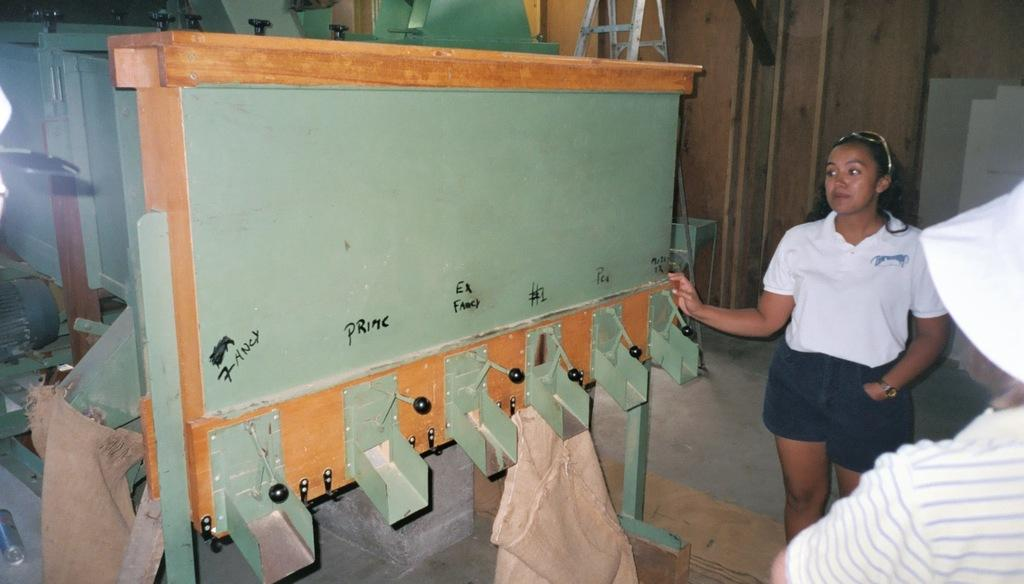How many people are in the image? There are two persons in the image. What object can be seen in the image that is used for climbing or reaching high places? There is a ladder in the image. What type of tools are visible in the image? There are grinders in the image. How many bags can be seen in the image? There are two woven bags in the image. Can you see a toad kissing one of the persons in the image? There is no toad or any kissing activity present in the image. 